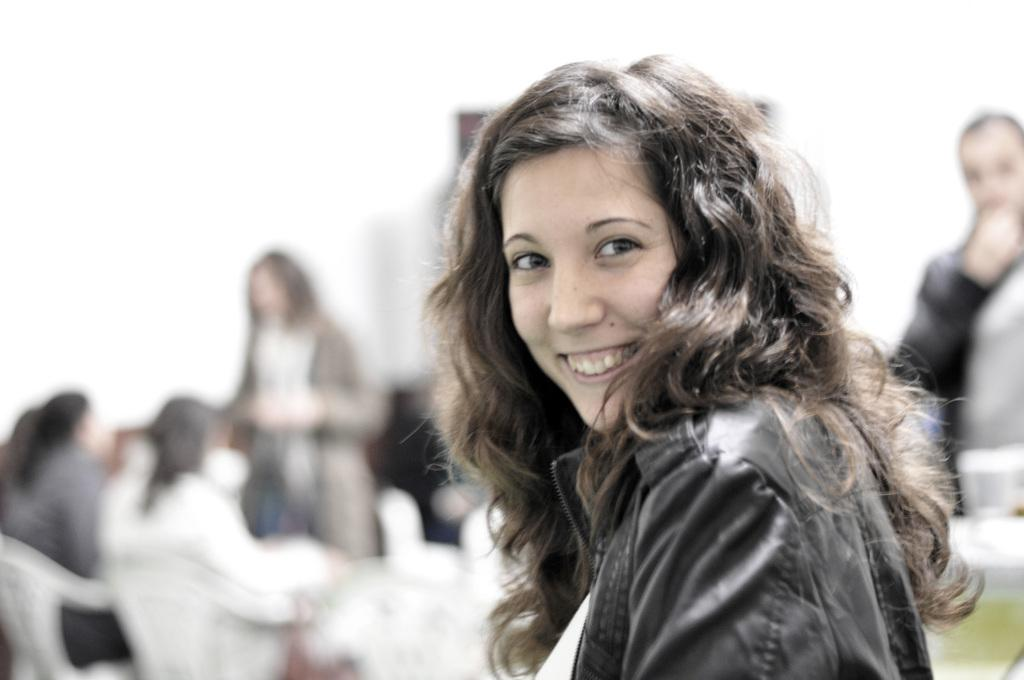Who is the main subject in the image? There is a woman in the image. What is the woman doing in the image? The woman is watching and smiling. What is the woman wearing in the image? The woman is wearing a jacket. Can you describe the background of the image? The background of the image is blurry. How many people are present in the image? There are people in the image. What are some of the people doing in the image? Some people are sitting on chairs, and some people are standing. How many frogs can be seen in the image? There are no frogs present in the image. What advice would the woman's grandmother give her in the image? There is no mention of a grandmother in the image, so it is not possible to answer this question. 